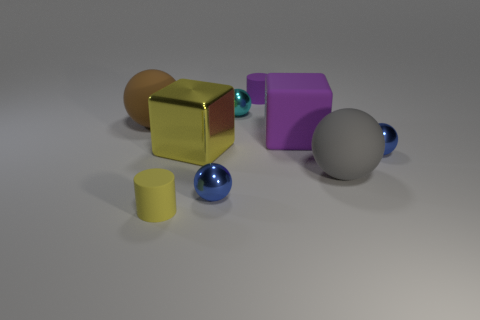Subtract all big brown matte balls. How many balls are left? 4 Subtract all gray balls. How many balls are left? 4 Subtract all cubes. How many objects are left? 7 Add 1 small blue cylinders. How many objects exist? 10 Subtract all gray spheres. Subtract all purple cylinders. How many spheres are left? 4 Subtract all gray blocks. How many red spheres are left? 0 Subtract all purple objects. Subtract all blocks. How many objects are left? 5 Add 5 large rubber things. How many large rubber things are left? 8 Add 6 small purple rubber things. How many small purple rubber things exist? 7 Subtract 0 green balls. How many objects are left? 9 